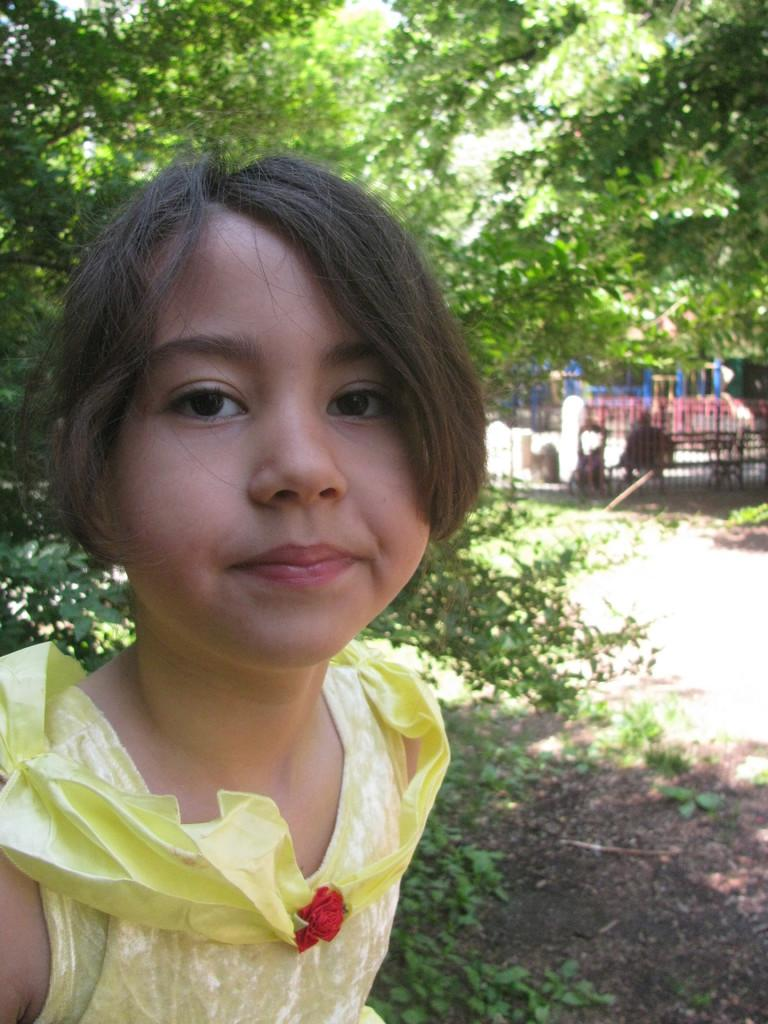Who is the main subject in the image? There is a girl in the image. What is the girl doing in the image? The girl is looking to one side. What is the girl wearing in the image? The girl is wearing a yellow dress. What can be seen in the background of the image? There are trees visible in the background of the image. How many eggs are present in the image? There are no eggs visible in the image. What is the temperature of the base in the image? There is no base or temperature mentioned in the image. 